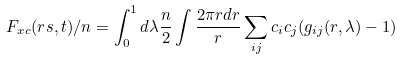Convert formula to latex. <formula><loc_0><loc_0><loc_500><loc_500>F _ { x c } ( r s , t ) / n = \int _ { 0 } ^ { 1 } d \lambda \frac { n } { 2 } \int \frac { 2 \pi r d r } { r } \sum _ { i j } c _ { i } c _ { j } ( g _ { i j } ( r , \lambda ) - 1 )</formula> 